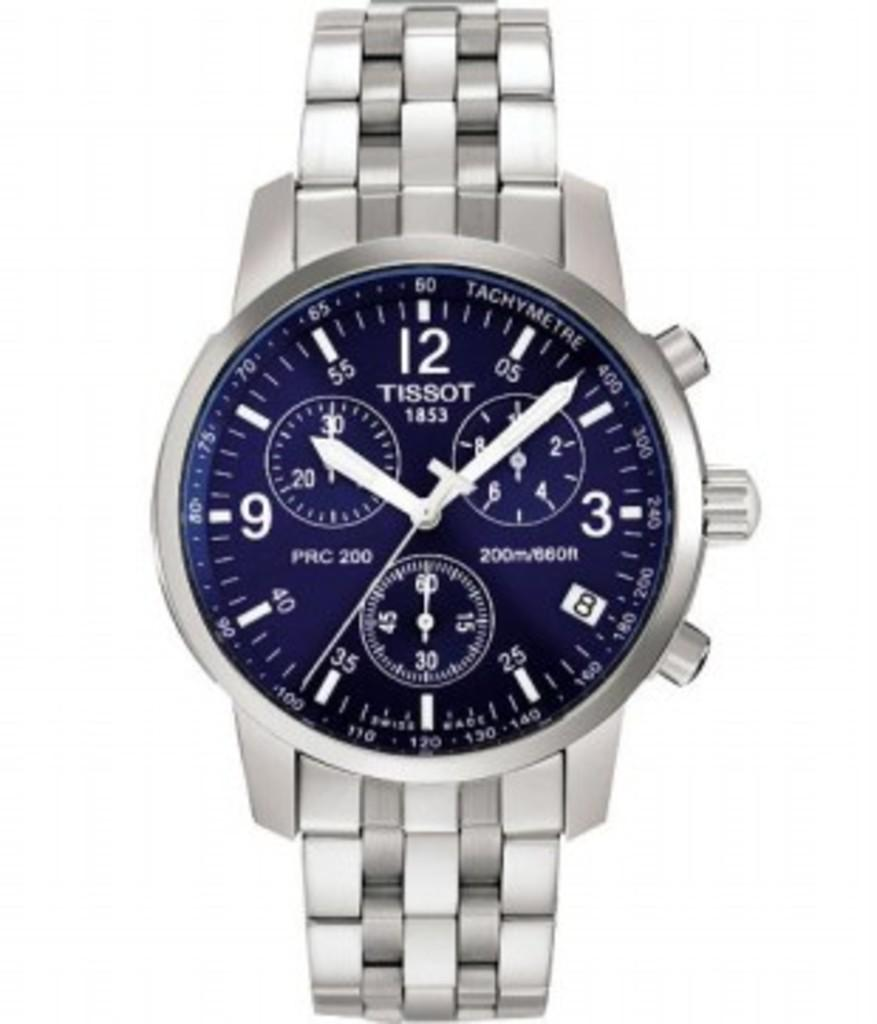<image>
Summarize the visual content of the image. The face of a blue watch made by Tissot 